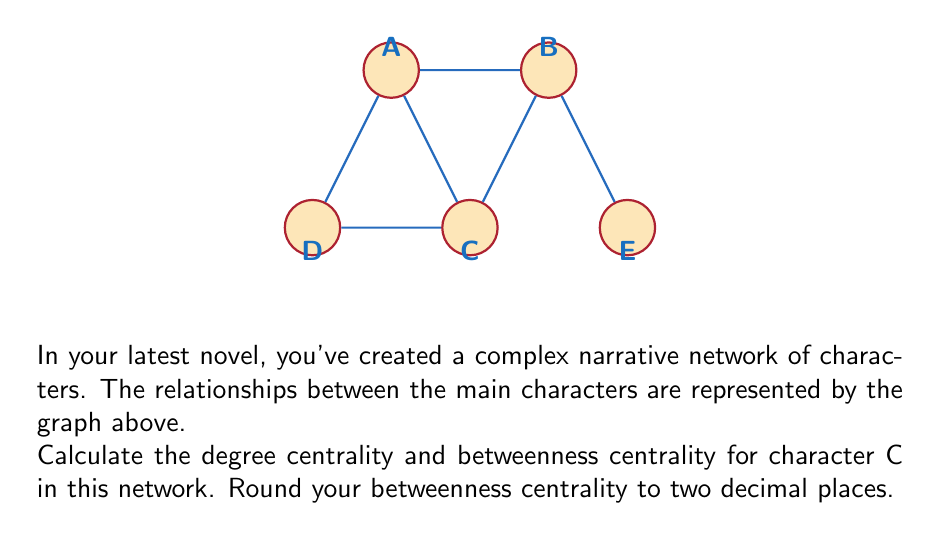Solve this math problem. To solve this problem, we'll calculate both the degree centrality and betweenness centrality for character C.

1. Degree Centrality:
   The degree centrality is the number of direct connections a node has.
   For character C:
   $$\text{Degree}(C) = 3$$
   
   To normalize this, we divide by the maximum possible degree (n-1, where n is the number of nodes):
   $$\text{Degree Centrality}(C) = \frac{3}{5-1} = \frac{3}{4} = 0.75$$

2. Betweenness Centrality:
   Betweenness centrality measures how often a node appears on the shortest paths between other nodes.
   
   First, we need to count the number of shortest paths between all pairs of nodes that pass through C:
   
   A-B: 1 path through C out of 2 total (A-B, A-C-B)
   A-E: 1 path through C out of 1 total (A-C-B-E)
   D-B: 1 path through C out of 1 total (D-C-B)
   D-E: 1 path through C out of 1 total (D-C-B-E)
   
   Sum of fractions: $\frac{1}{2} + 1 + 1 + 1 = \frac{7}{2} = 3.5$
   
   To normalize, we divide by the total number of pairs of nodes excluding C:
   $$\text{Total pairs} = \frac{(n-1)(n-2)}{2} = \frac{(5-1)(5-2)}{2} = 6$$
   
   $$\text{Betweenness Centrality}(C) = \frac{3.5}{6} \approx 0.58$$

Thus, the degree centrality is 0.75 and the betweenness centrality (rounded to two decimal places) is 0.58.
Answer: Degree Centrality: 0.75, Betweenness Centrality: 0.58 